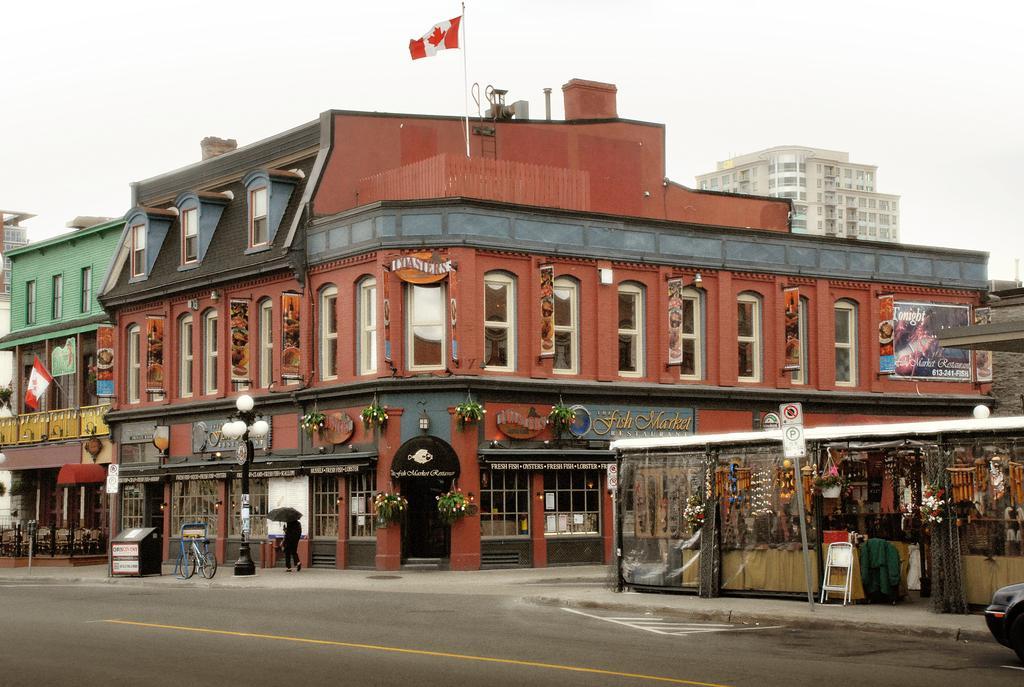Can you describe this image briefly? In this image I can see the road, a car, the sidewalk, a person standing on the sidewalk, few boards, few poles, few plants and few buildings. In the background I can see the sky. 